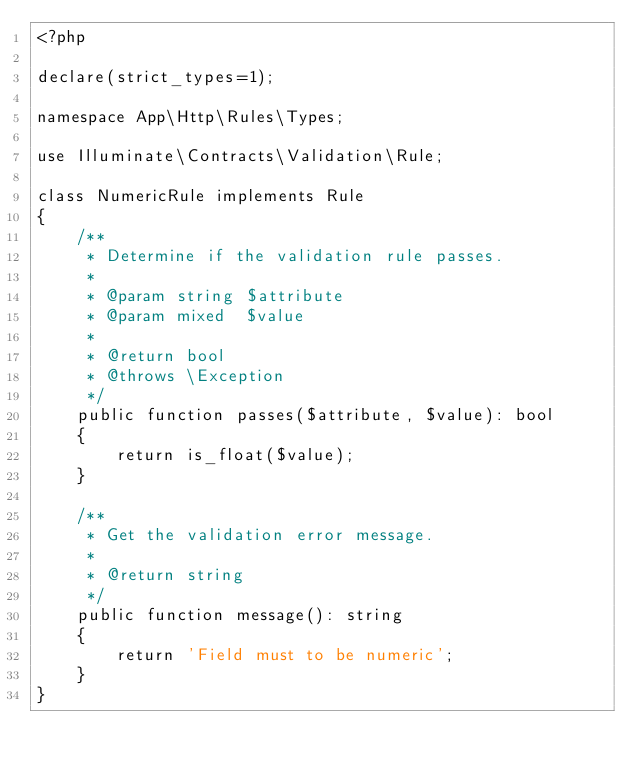Convert code to text. <code><loc_0><loc_0><loc_500><loc_500><_PHP_><?php

declare(strict_types=1);

namespace App\Http\Rules\Types;

use Illuminate\Contracts\Validation\Rule;

class NumericRule implements Rule
{
    /**
     * Determine if the validation rule passes.
     *
     * @param string $attribute
     * @param mixed  $value
     *
     * @return bool
     * @throws \Exception
     */
    public function passes($attribute, $value): bool
    {
        return is_float($value);
    }

    /**
     * Get the validation error message.
     *
     * @return string
     */
    public function message(): string
    {
        return 'Field must to be numeric';
    }
}
</code> 